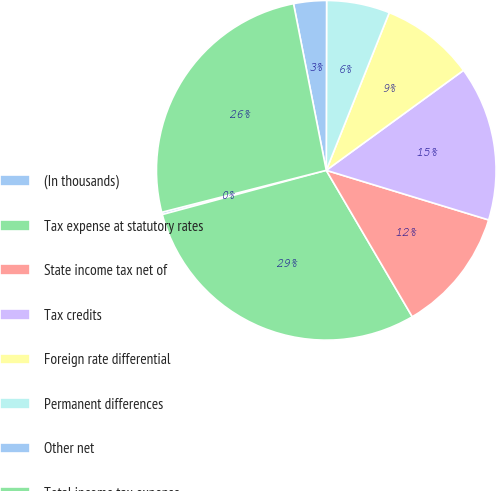Convert chart to OTSL. <chart><loc_0><loc_0><loc_500><loc_500><pie_chart><fcel>(In thousands)<fcel>Tax expense at statutory rates<fcel>State income tax net of<fcel>Tax credits<fcel>Foreign rate differential<fcel>Permanent differences<fcel>Other net<fcel>Total income tax expense<nl><fcel>0.22%<fcel>29.26%<fcel>11.83%<fcel>14.74%<fcel>8.93%<fcel>6.02%<fcel>3.12%<fcel>25.89%<nl></chart> 